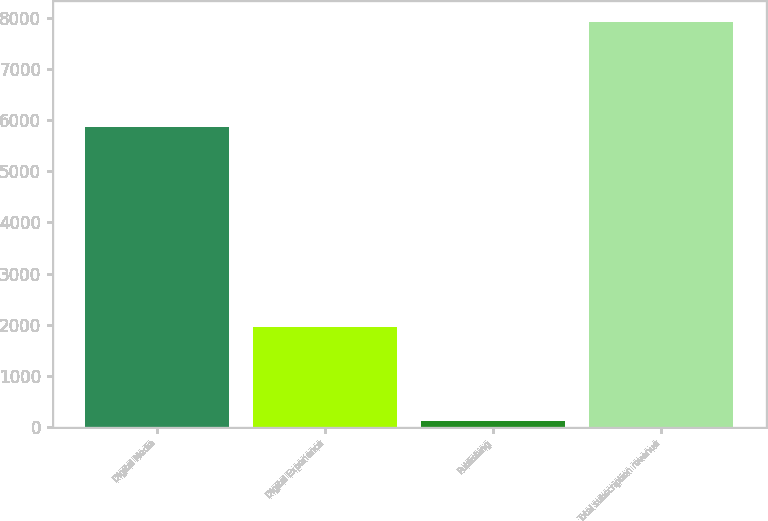<chart> <loc_0><loc_0><loc_500><loc_500><bar_chart><fcel>Digital Media<fcel>Digital Experience<fcel>Publishing<fcel>Total subscription revenue<nl><fcel>5857.7<fcel>1949.3<fcel>115.2<fcel>7922.2<nl></chart> 